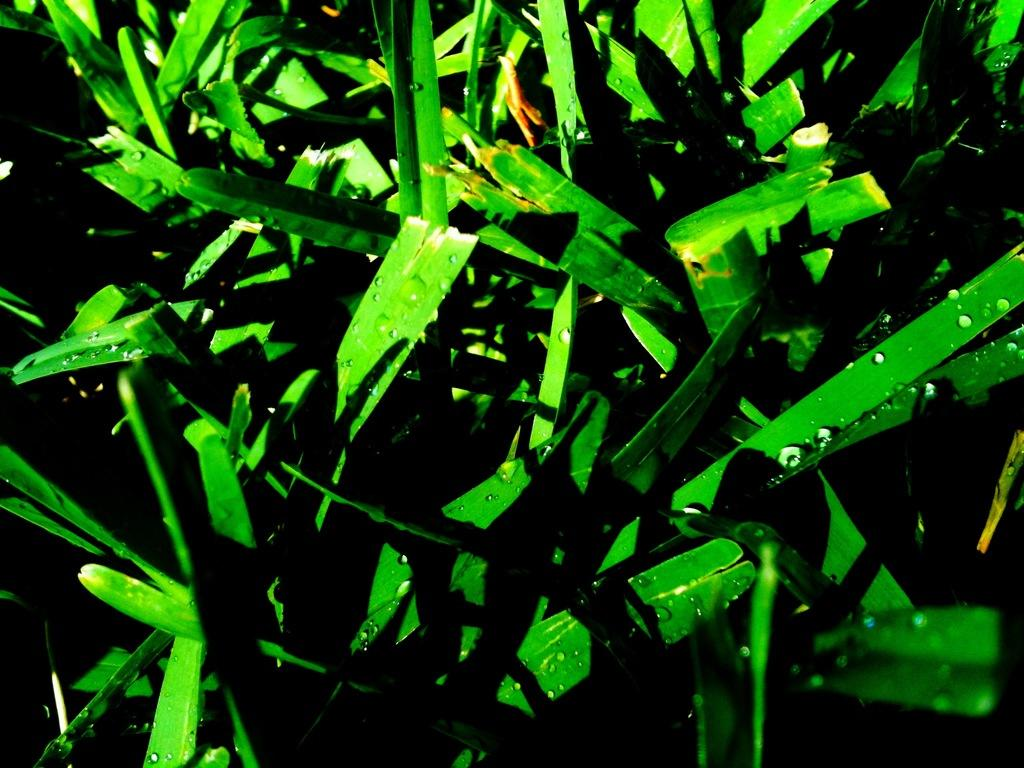What is present on the leafs in the image? There are droplets on the leafs in the image. Can you describe the appearance of the droplets? The droplets appear to be small and round, likely due to moisture or dew. What might be the cause of the droplets on the leafs? The droplets could be caused by condensation, rain, or morning dew. How many children are playing with the record in the image? There are no children or records present in the image; it only features droplets on leafs. What type of cattle can be seen grazing in the image? There are no cattle present in the image; it only features droplets on leafs. 